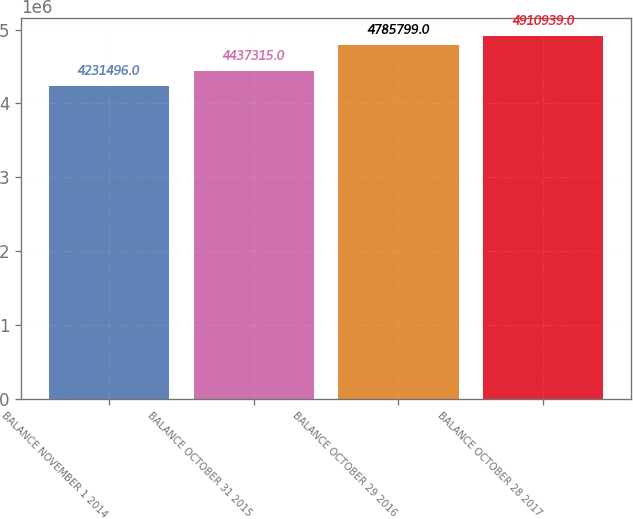Convert chart. <chart><loc_0><loc_0><loc_500><loc_500><bar_chart><fcel>BALANCE NOVEMBER 1 2014<fcel>BALANCE OCTOBER 31 2015<fcel>BALANCE OCTOBER 29 2016<fcel>BALANCE OCTOBER 28 2017<nl><fcel>4.2315e+06<fcel>4.43732e+06<fcel>4.7858e+06<fcel>4.91094e+06<nl></chart> 